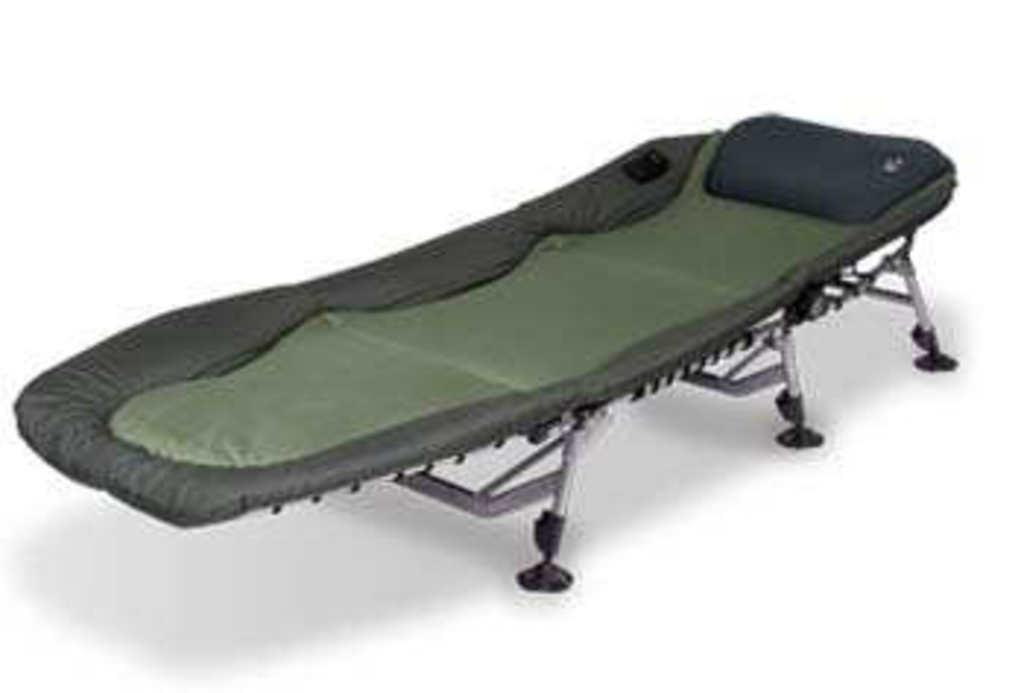What is the main object in the center of the image? There is a leg stretcher in the center of the image. How many zebras can be seen using the leg stretcher in the image? There are no zebras present in the image, and the leg stretcher is not being used by any animals. 